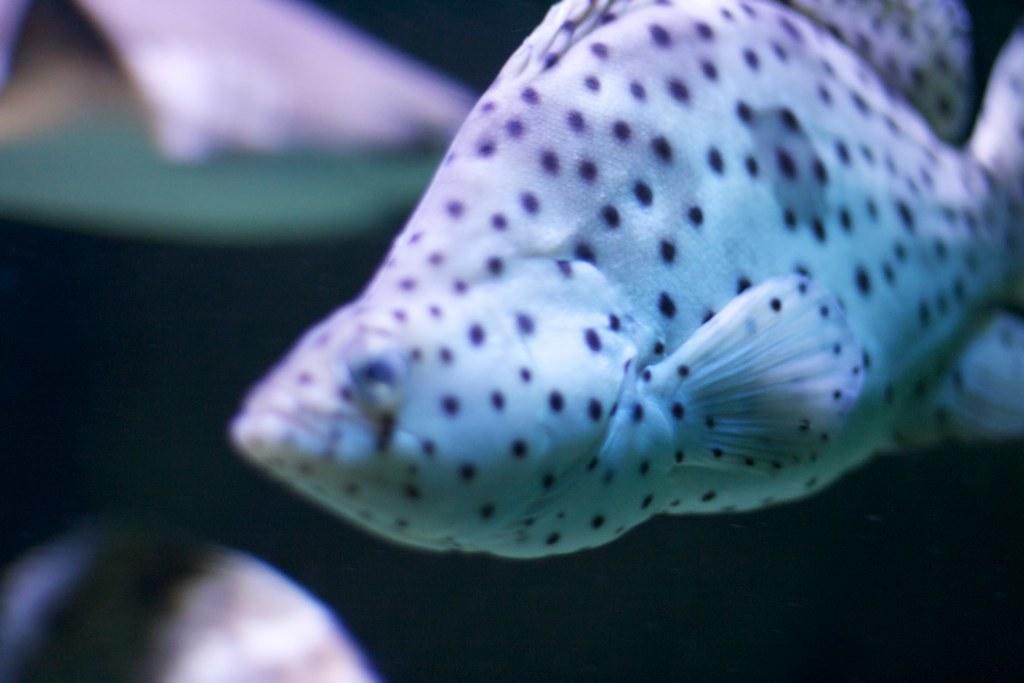Could you give a brief overview of what you see in this image? In this image in the foreground there is one fish, and in the background there are two fishes. 